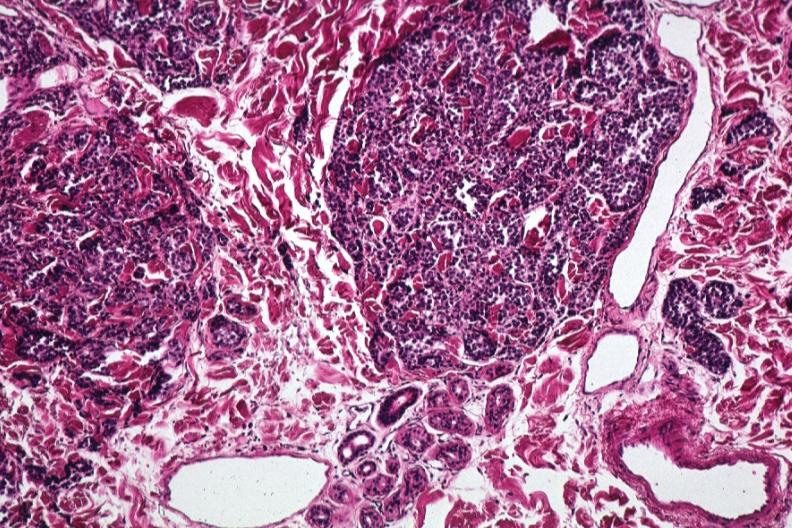where is this?
Answer the question using a single word or phrase. Skin 